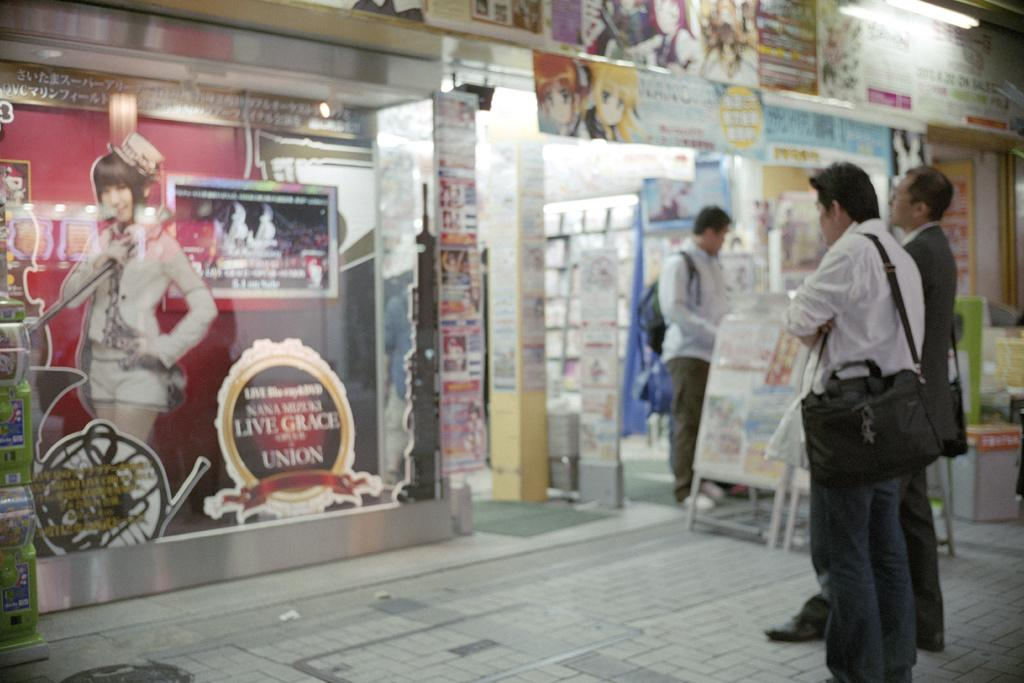Provide a one-sentence caption for the provided image. Tourists are standing outside a store front that has a Live Grace sign. 